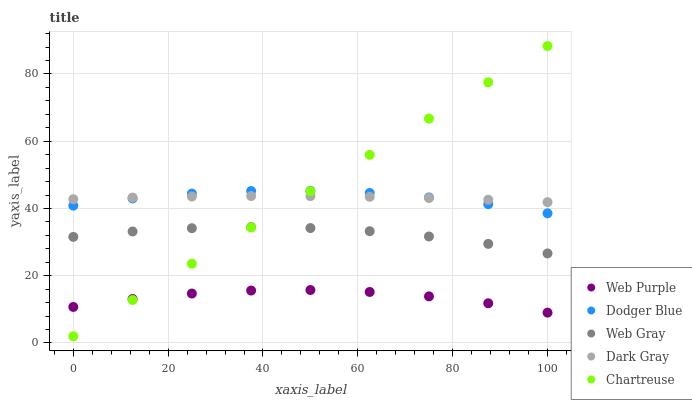Does Web Purple have the minimum area under the curve?
Answer yes or no. Yes. Does Chartreuse have the maximum area under the curve?
Answer yes or no. Yes. Does Web Gray have the minimum area under the curve?
Answer yes or no. No. Does Web Gray have the maximum area under the curve?
Answer yes or no. No. Is Chartreuse the smoothest?
Answer yes or no. Yes. Is Web Purple the roughest?
Answer yes or no. Yes. Is Web Gray the smoothest?
Answer yes or no. No. Is Web Gray the roughest?
Answer yes or no. No. Does Chartreuse have the lowest value?
Answer yes or no. Yes. Does Web Purple have the lowest value?
Answer yes or no. No. Does Chartreuse have the highest value?
Answer yes or no. Yes. Does Web Gray have the highest value?
Answer yes or no. No. Is Web Purple less than Dodger Blue?
Answer yes or no. Yes. Is Web Gray greater than Web Purple?
Answer yes or no. Yes. Does Chartreuse intersect Web Purple?
Answer yes or no. Yes. Is Chartreuse less than Web Purple?
Answer yes or no. No. Is Chartreuse greater than Web Purple?
Answer yes or no. No. Does Web Purple intersect Dodger Blue?
Answer yes or no. No. 